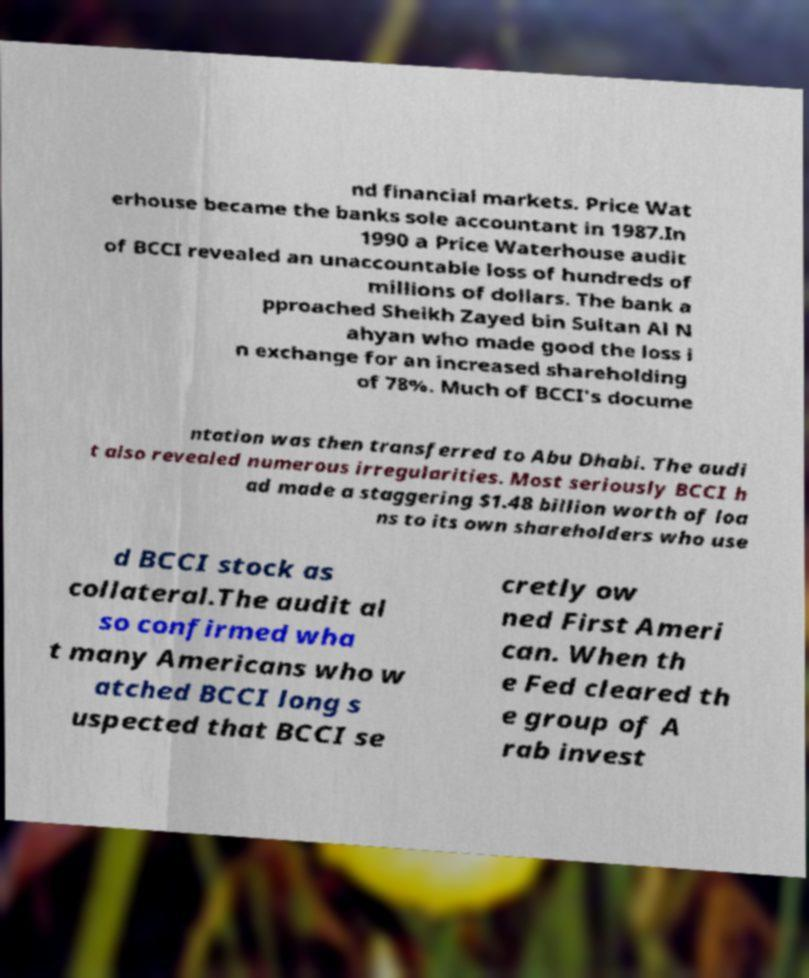Please read and relay the text visible in this image. What does it say? nd financial markets. Price Wat erhouse became the banks sole accountant in 1987.In 1990 a Price Waterhouse audit of BCCI revealed an unaccountable loss of hundreds of millions of dollars. The bank a pproached Sheikh Zayed bin Sultan Al N ahyan who made good the loss i n exchange for an increased shareholding of 78%. Much of BCCI's docume ntation was then transferred to Abu Dhabi. The audi t also revealed numerous irregularities. Most seriously BCCI h ad made a staggering $1.48 billion worth of loa ns to its own shareholders who use d BCCI stock as collateral.The audit al so confirmed wha t many Americans who w atched BCCI long s uspected that BCCI se cretly ow ned First Ameri can. When th e Fed cleared th e group of A rab invest 